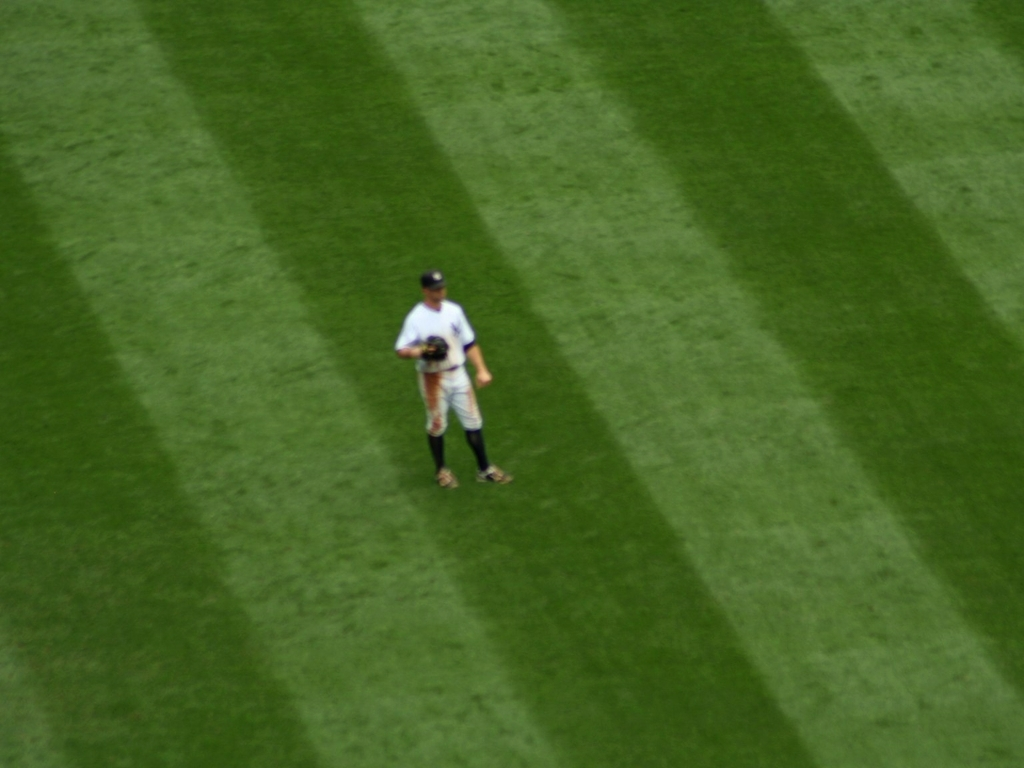What makes it difficult to distinguish the texture of the lawn and person's details?
A. High clarity
B. Blurry focus
C. Low clarity
D. Good lighting
Answer with the option's letter from the given choices directly. The difficulty in distinguishing the texture of the lawn and the person's details in the image can be attributed to blurry focus, option 'B'. This is because the lack of sharpness and precision in the image obscure the fine details, resulting in a diffuse appearance where both the lawn and the person blend into each other without clear boundaries or textures. 